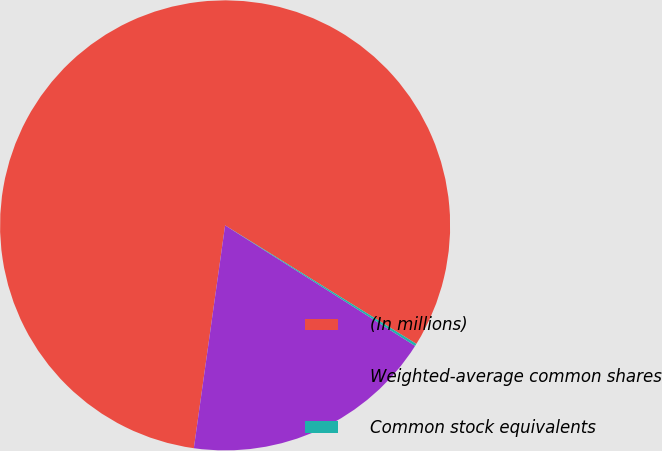Convert chart. <chart><loc_0><loc_0><loc_500><loc_500><pie_chart><fcel>(In millions)<fcel>Weighted-average common shares<fcel>Common stock equivalents<nl><fcel>81.61%<fcel>18.22%<fcel>0.17%<nl></chart> 